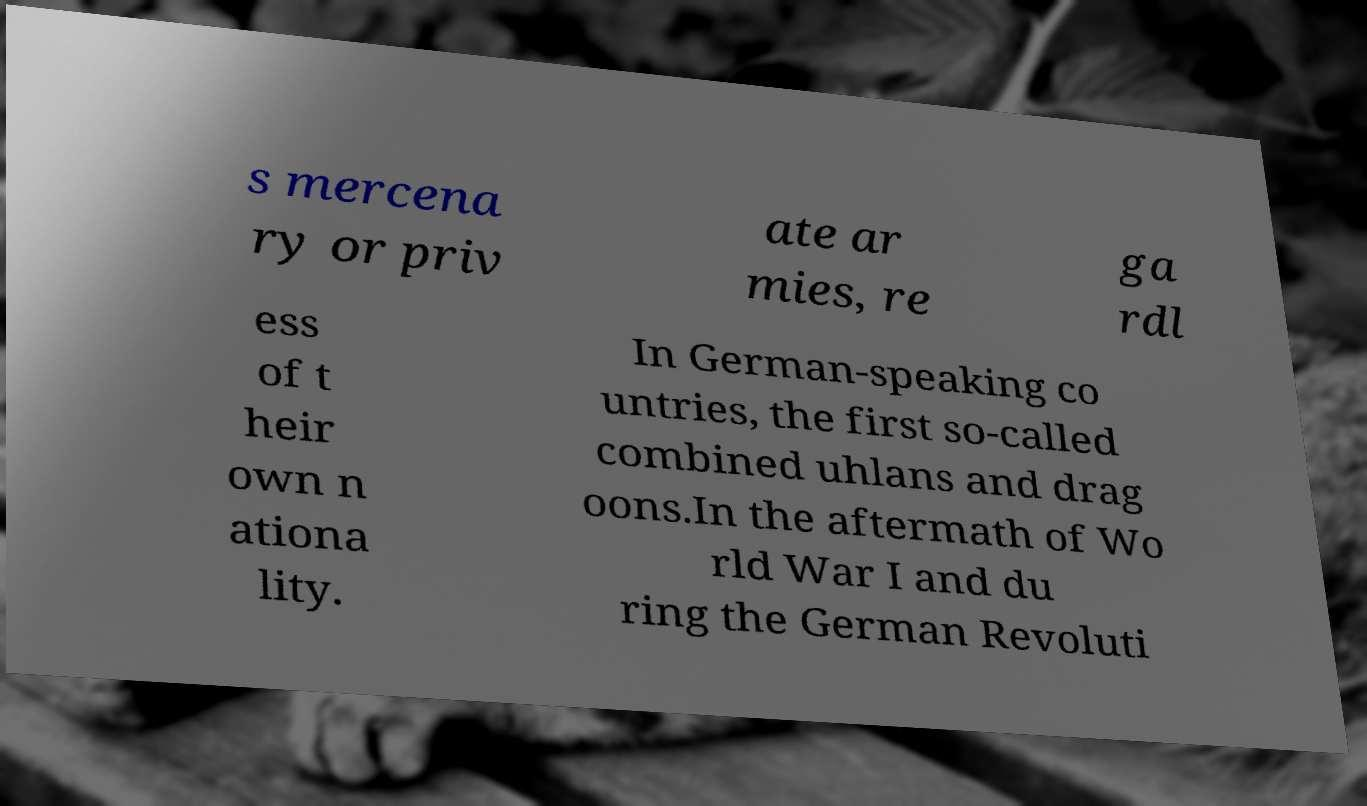Could you assist in decoding the text presented in this image and type it out clearly? s mercena ry or priv ate ar mies, re ga rdl ess of t heir own n ationa lity. In German-speaking co untries, the first so-called combined uhlans and drag oons.In the aftermath of Wo rld War I and du ring the German Revoluti 